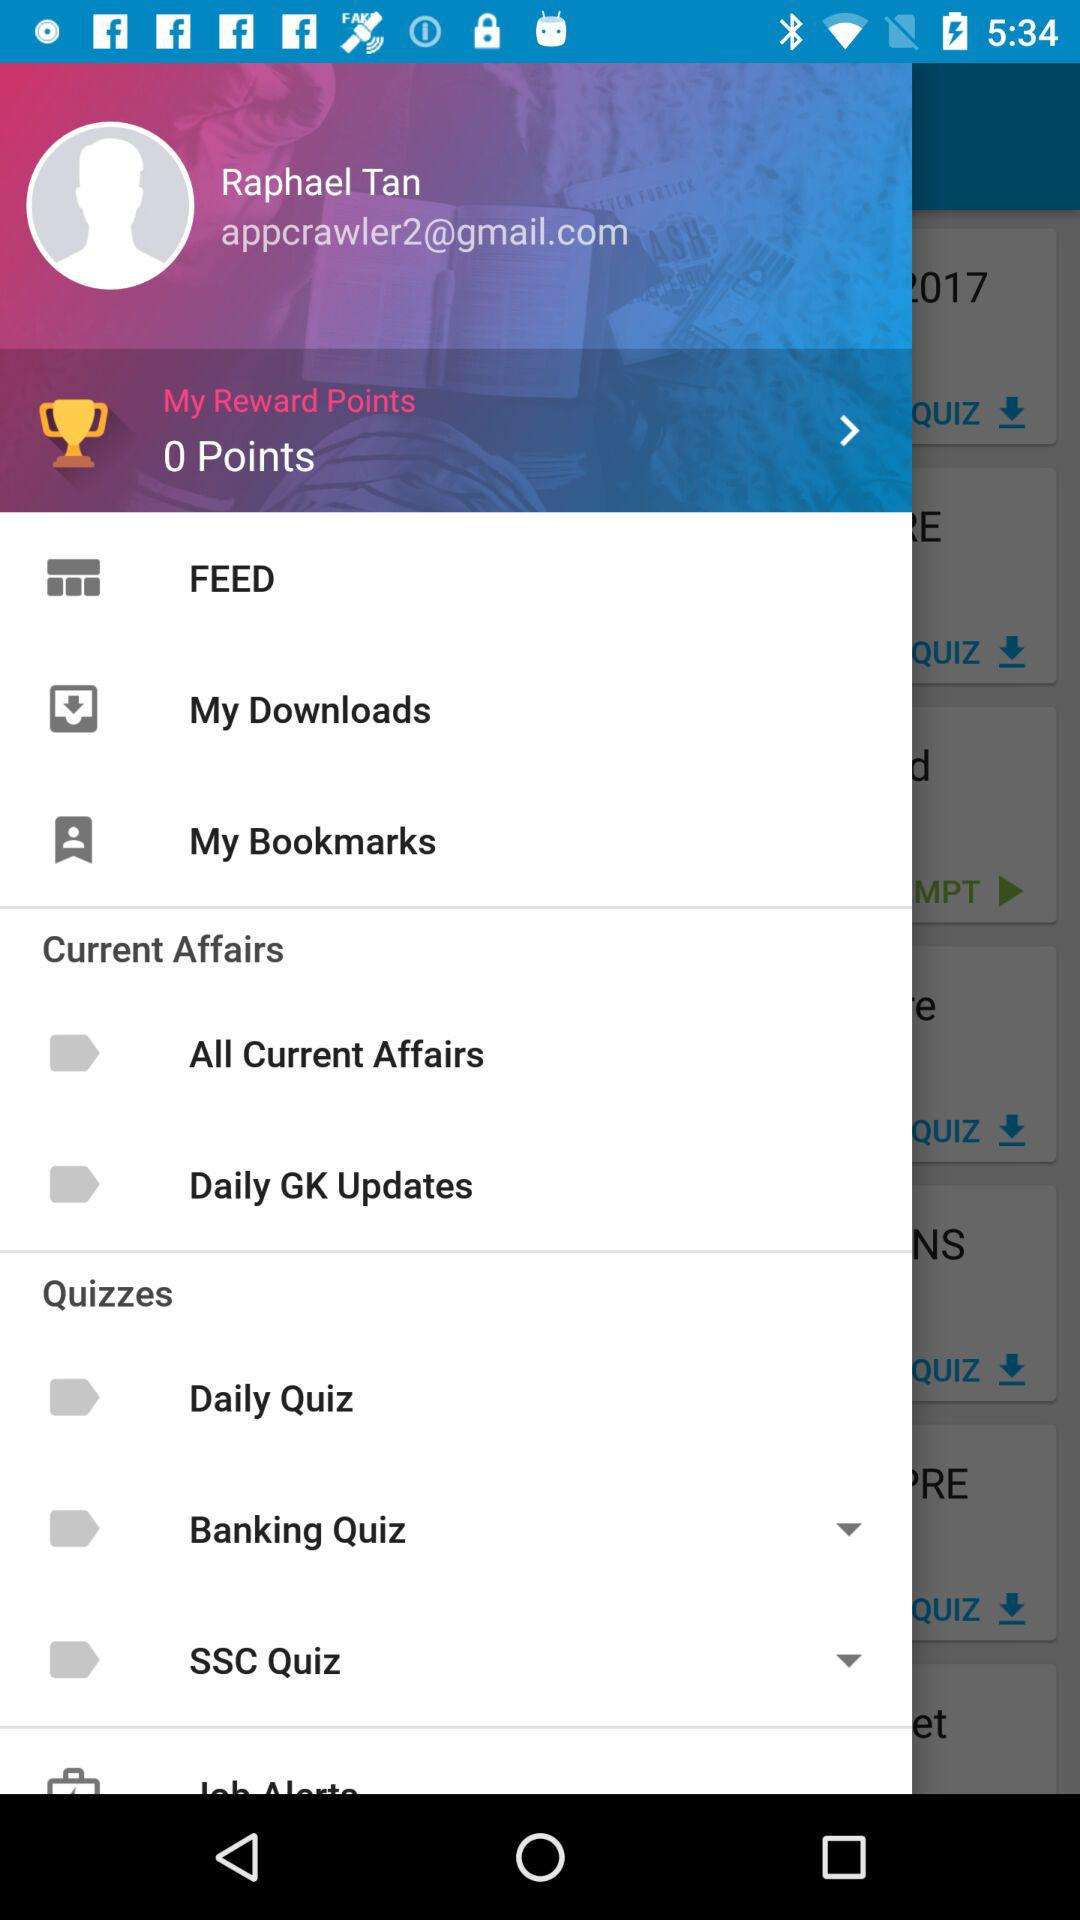What is the email address? The email address is appcrawler2@gmail.com. 